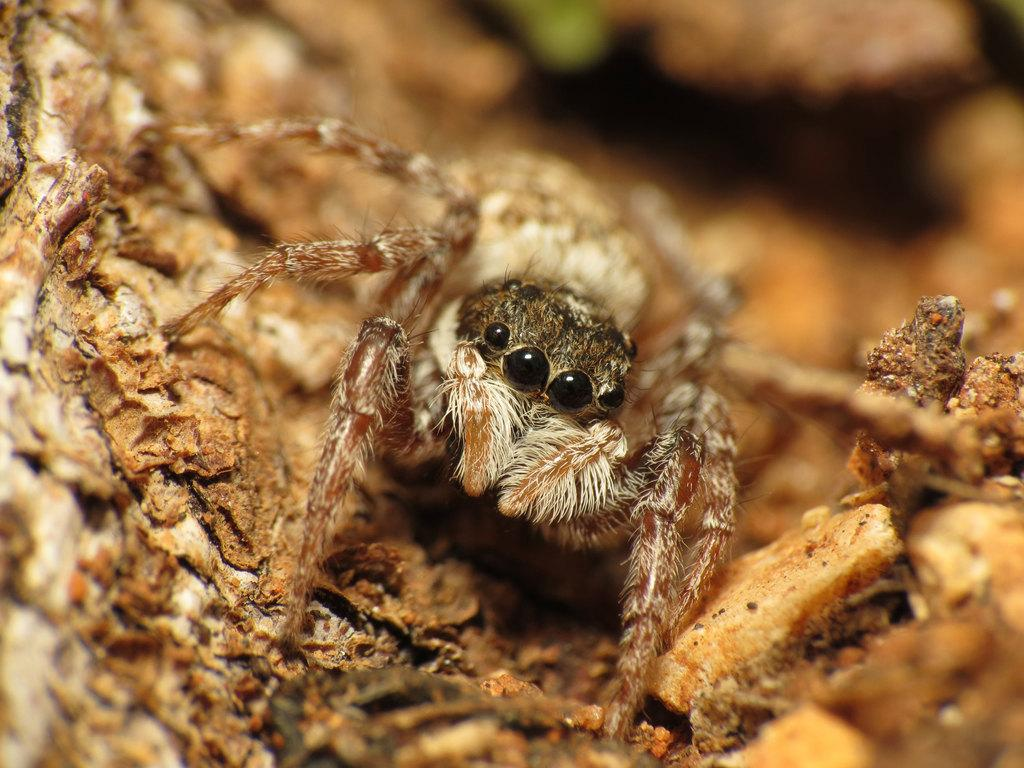What is the main subject of the image? There is a spider in the image. Where is the spider located? The spider is on a piece of wood. Can you describe the background of the image? The background of the image is blurry. What type of lamp is hanging above the spider in the image? There is no lamp present in the image; it only features a spider on a piece of wood with a blurry background. 